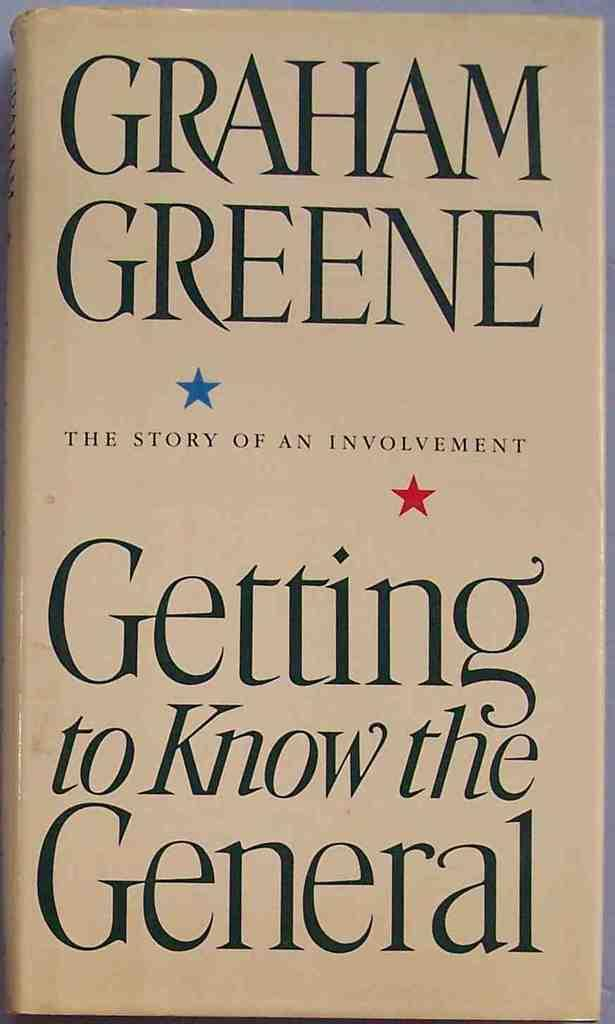<image>
Present a compact description of the photo's key features. A book cover titled "Getting to Know the General". 